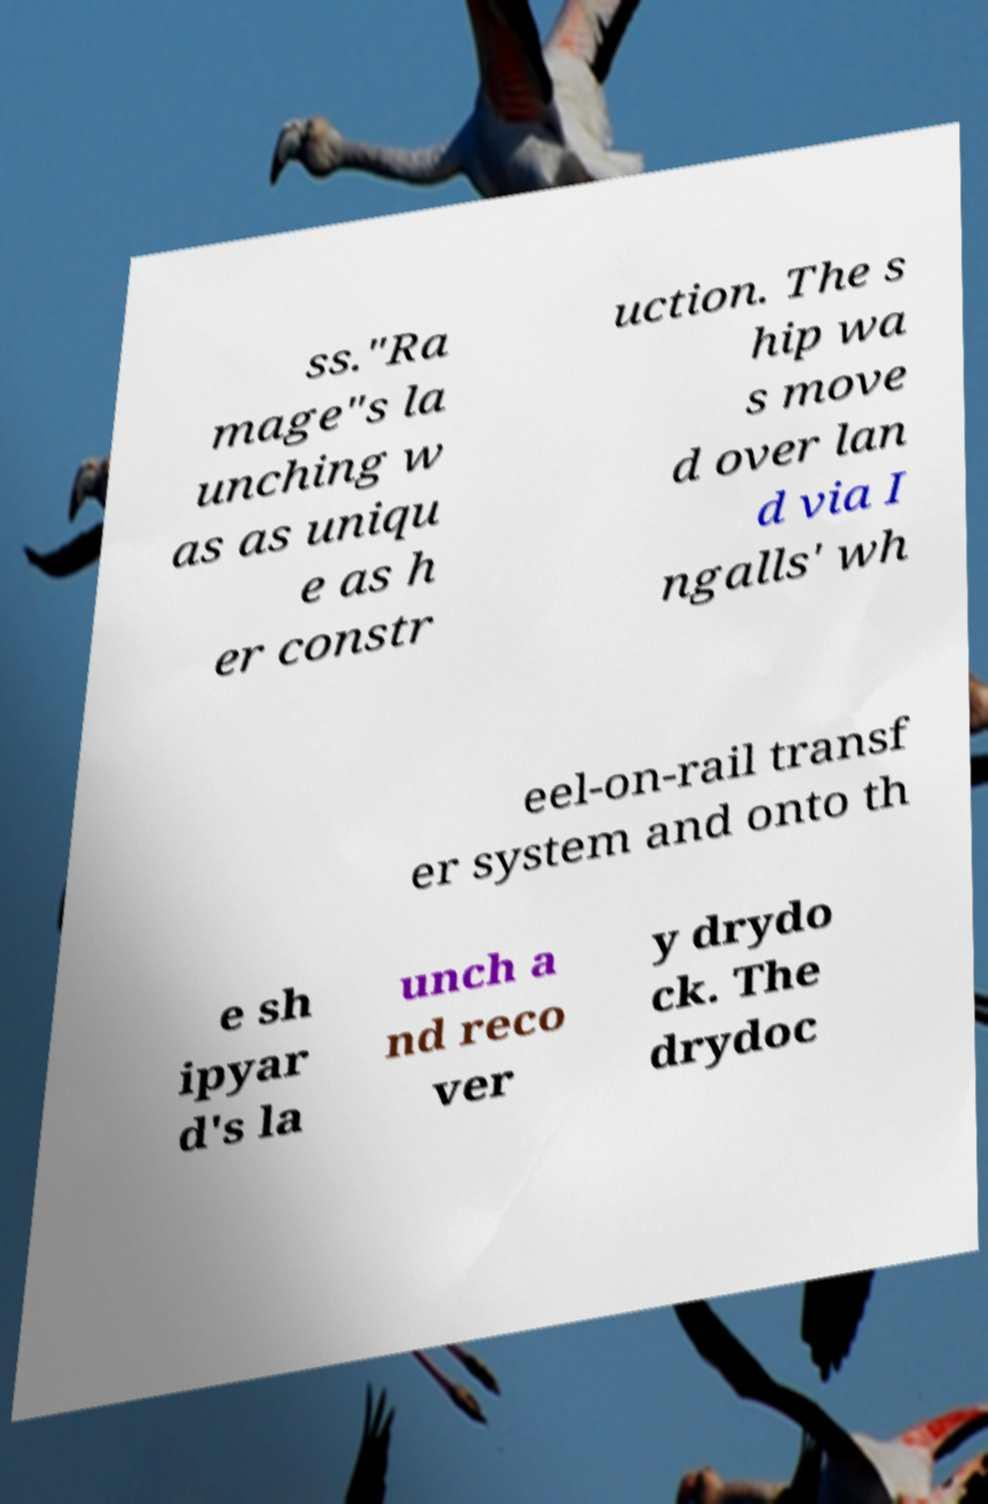Could you extract and type out the text from this image? ss."Ra mage"s la unching w as as uniqu e as h er constr uction. The s hip wa s move d over lan d via I ngalls' wh eel-on-rail transf er system and onto th e sh ipyar d's la unch a nd reco ver y drydo ck. The drydoc 